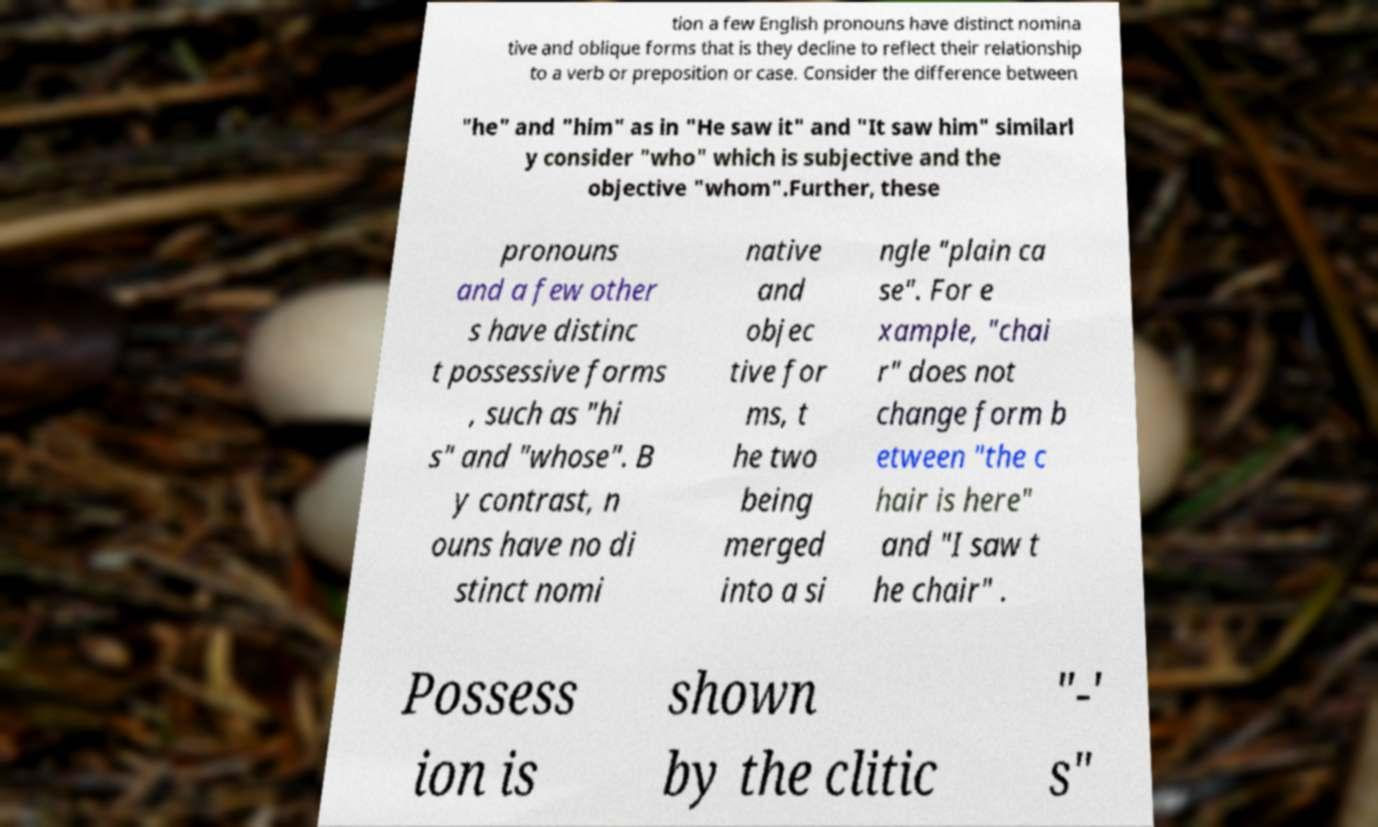Please read and relay the text visible in this image. What does it say? tion a few English pronouns have distinct nomina tive and oblique forms that is they decline to reflect their relationship to a verb or preposition or case. Consider the difference between "he" and "him" as in "He saw it" and "It saw him" similarl y consider "who" which is subjective and the objective "whom".Further, these pronouns and a few other s have distinc t possessive forms , such as "hi s" and "whose". B y contrast, n ouns have no di stinct nomi native and objec tive for ms, t he two being merged into a si ngle "plain ca se". For e xample, "chai r" does not change form b etween "the c hair is here" and "I saw t he chair" . Possess ion is shown by the clitic "-' s" 